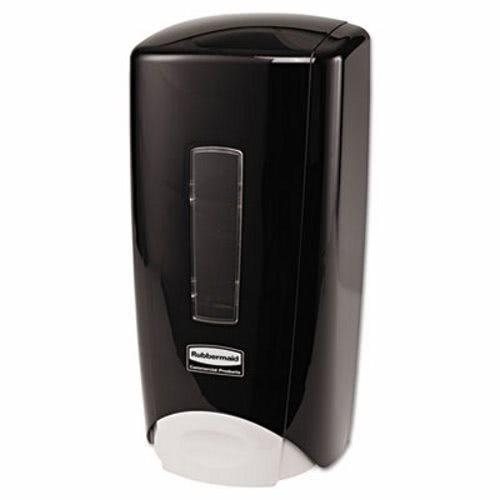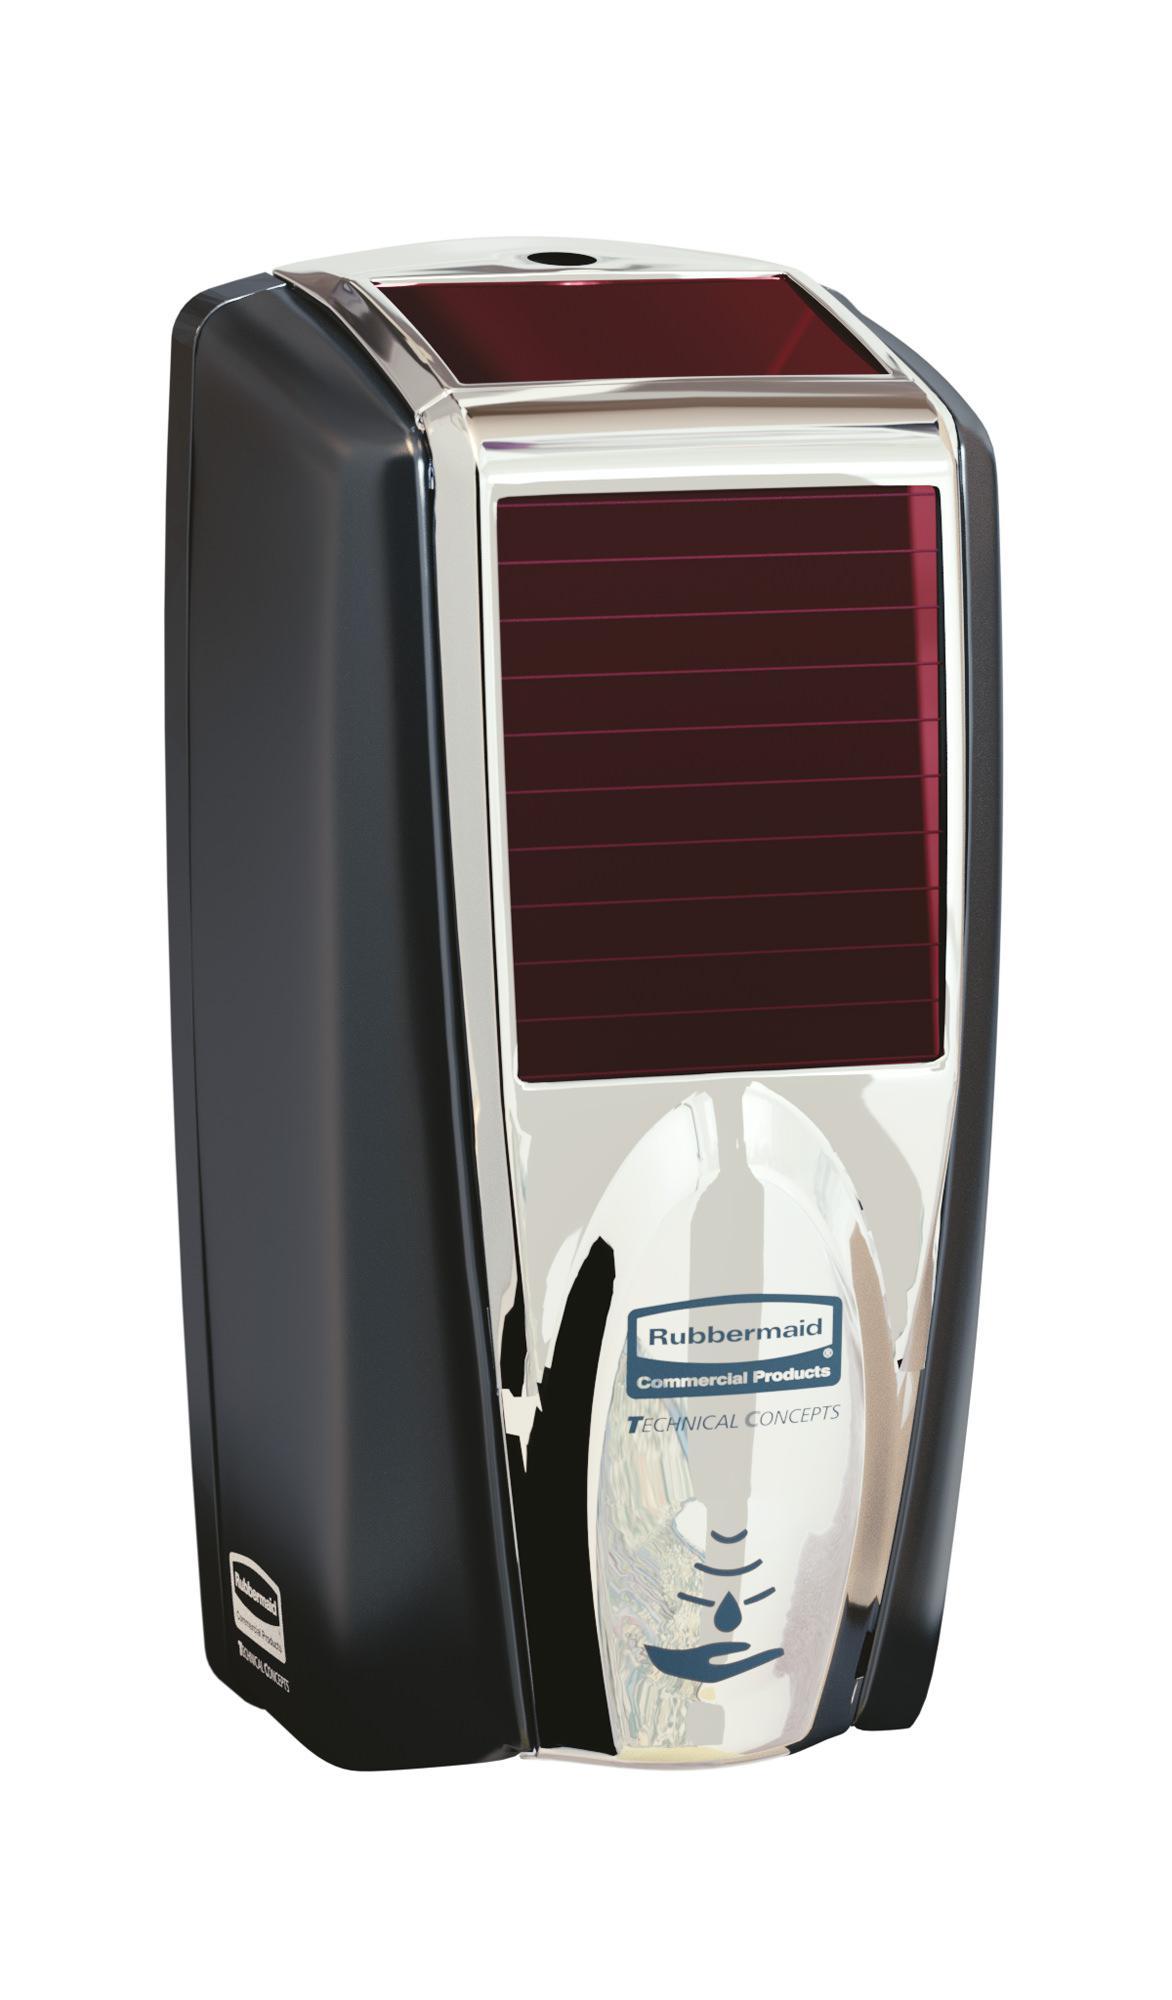The first image is the image on the left, the second image is the image on the right. Analyze the images presented: Is the assertion "There are exactly two dispensers." valid? Answer yes or no. Yes. The first image is the image on the left, the second image is the image on the right. Assess this claim about the two images: "The left and right image contains the same number of wall hanging soap dispensers.". Correct or not? Answer yes or no. Yes. 